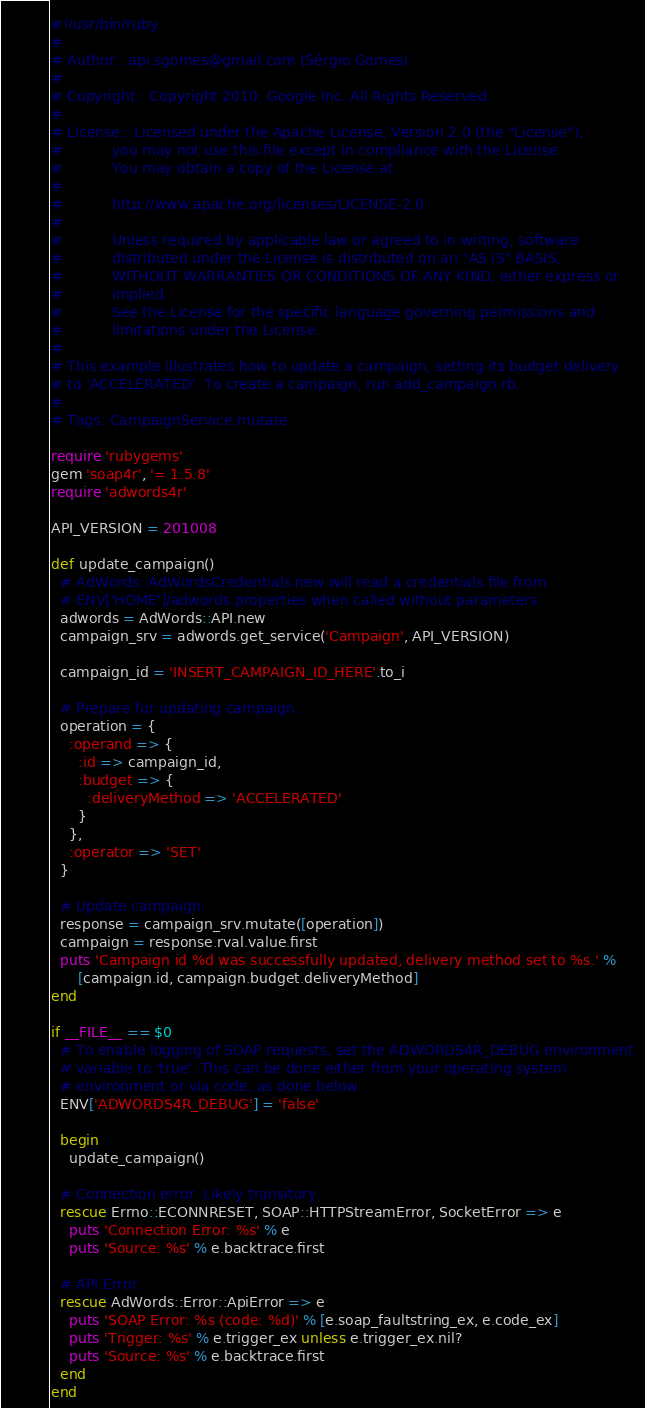<code> <loc_0><loc_0><loc_500><loc_500><_Ruby_>#!/usr/bin/ruby
#
# Author:: api.sgomes@gmail.com (Sérgio Gomes)
#
# Copyright:: Copyright 2010, Google Inc. All Rights Reserved.
#
# License:: Licensed under the Apache License, Version 2.0 (the "License");
#           you may not use this file except in compliance with the License.
#           You may obtain a copy of the License at
#
#           http://www.apache.org/licenses/LICENSE-2.0
#
#           Unless required by applicable law or agreed to in writing, software
#           distributed under the License is distributed on an "AS IS" BASIS,
#           WITHOUT WARRANTIES OR CONDITIONS OF ANY KIND, either express or
#           implied.
#           See the License for the specific language governing permissions and
#           limitations under the License.
#
# This example illustrates how to update a campaign, setting its budget delivery
# to 'ACCELERATED'. To create a campaign, run add_campaign.rb.
#
# Tags: CampaignService.mutate

require 'rubygems'
gem 'soap4r', '= 1.5.8'
require 'adwords4r'

API_VERSION = 201008

def update_campaign()
  # AdWords::AdWordsCredentials.new will read a credentials file from
  # ENV['HOME']/adwords.properties when called without parameters.
  adwords = AdWords::API.new
  campaign_srv = adwords.get_service('Campaign', API_VERSION)

  campaign_id = 'INSERT_CAMPAIGN_ID_HERE'.to_i

  # Prepare for updating campaign.
  operation = {
    :operand => {
      :id => campaign_id,
      :budget => {
        :deliveryMethod => 'ACCELERATED'
      }
    },
    :operator => 'SET'
  }

  # Update campaign.
  response = campaign_srv.mutate([operation])
  campaign = response.rval.value.first
  puts 'Campaign id %d was successfully updated, delivery method set to %s.' %
      [campaign.id, campaign.budget.deliveryMethod]
end

if __FILE__ == $0
  # To enable logging of SOAP requests, set the ADWORDS4R_DEBUG environment
  # variable to 'true'. This can be done either from your operating system
  # environment or via code, as done below.
  ENV['ADWORDS4R_DEBUG'] = 'false'

  begin
    update_campaign()

  # Connection error. Likely transitory.
  rescue Errno::ECONNRESET, SOAP::HTTPStreamError, SocketError => e
    puts 'Connection Error: %s' % e
    puts 'Source: %s' % e.backtrace.first

  # API Error.
  rescue AdWords::Error::ApiError => e
    puts 'SOAP Error: %s (code: %d)' % [e.soap_faultstring_ex, e.code_ex]
    puts 'Trigger: %s' % e.trigger_ex unless e.trigger_ex.nil?
    puts 'Source: %s' % e.backtrace.first
  end
end
</code> 